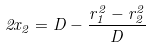Convert formula to latex. <formula><loc_0><loc_0><loc_500><loc_500>2 x _ { 2 } = D - \frac { r _ { 1 } ^ { 2 } - r _ { 2 } ^ { 2 } } { D }</formula> 